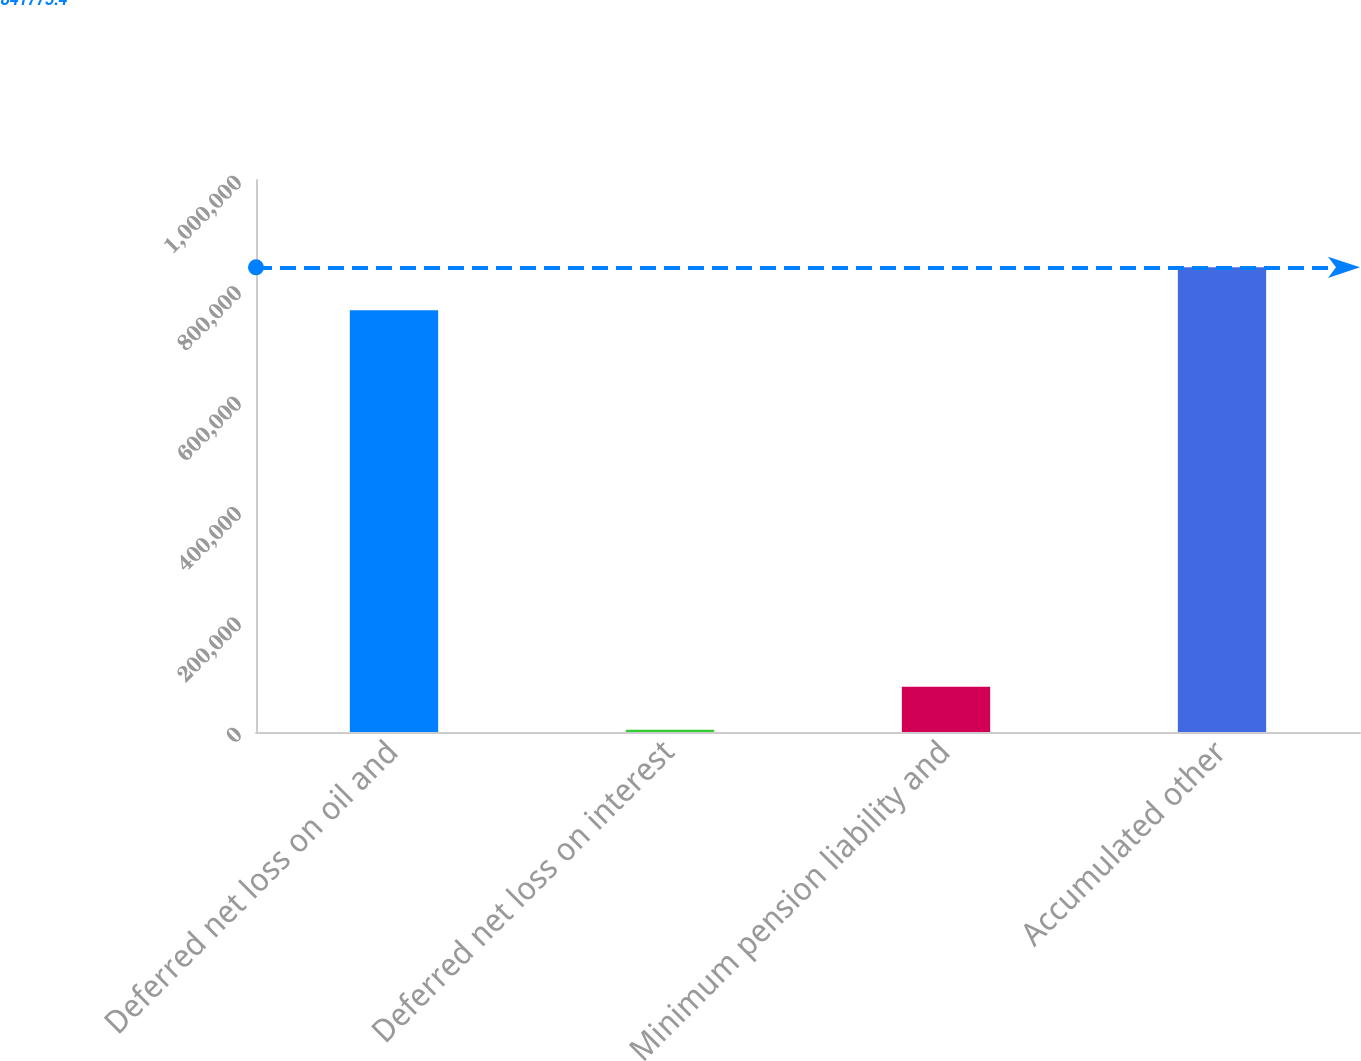Convert chart. <chart><loc_0><loc_0><loc_500><loc_500><bar_chart><fcel>Deferred net loss on oil and<fcel>Deferred net loss on interest<fcel>Minimum pension liability and<fcel>Accumulated other<nl><fcel>763834<fcel>4085<fcel>82026.4<fcel>841775<nl></chart> 